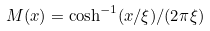Convert formula to latex. <formula><loc_0><loc_0><loc_500><loc_500>M ( x ) = \cosh ^ { - 1 } ( x / \xi ) / ( 2 \pi \xi )</formula> 